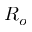Convert formula to latex. <formula><loc_0><loc_0><loc_500><loc_500>R _ { o }</formula> 